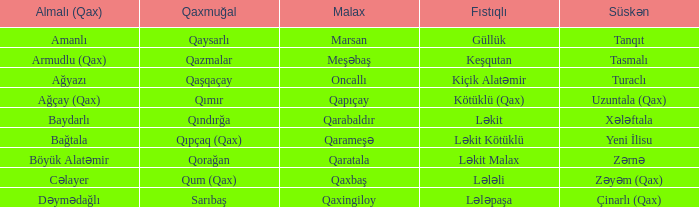What is the Süskən village with a Malax village meşəbaş? Tasmalı. 